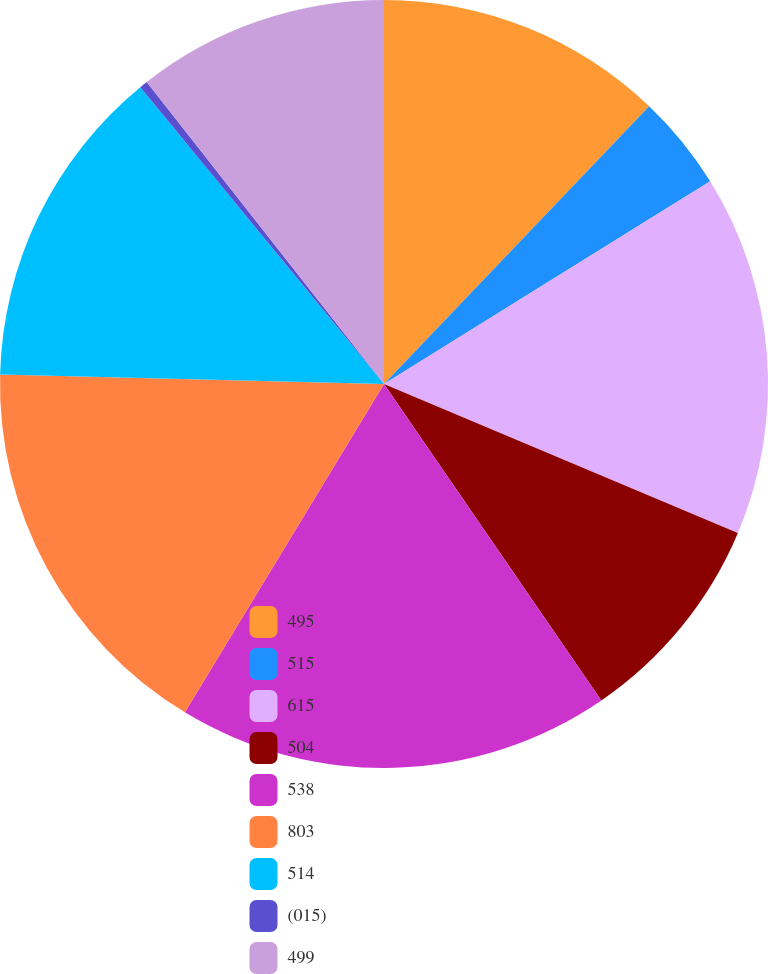<chart> <loc_0><loc_0><loc_500><loc_500><pie_chart><fcel>495<fcel>515<fcel>615<fcel>504<fcel>538<fcel>803<fcel>514<fcel>(015)<fcel>499<nl><fcel>12.13%<fcel>4.02%<fcel>15.19%<fcel>9.08%<fcel>18.25%<fcel>16.72%<fcel>13.66%<fcel>0.34%<fcel>10.6%<nl></chart> 